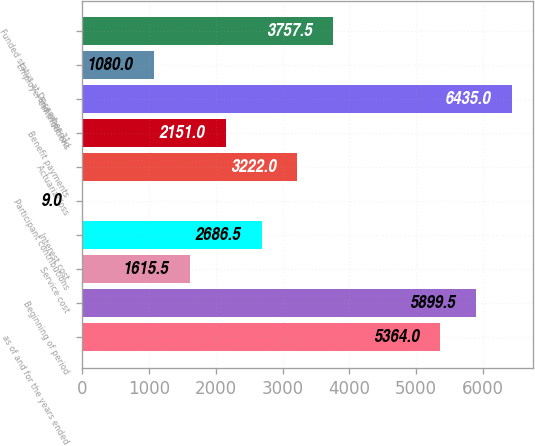Convert chart to OTSL. <chart><loc_0><loc_0><loc_500><loc_500><bar_chart><fcel>as of and for the years ended<fcel>Beginning of period<fcel>Service cost<fcel>Interest cost<fcel>Participant contributions<fcel>Actuarial loss<fcel>Benefit payments<fcel>End of period<fcel>Employer contributions<fcel>Funded status at December 31<nl><fcel>5364<fcel>5899.5<fcel>1615.5<fcel>2686.5<fcel>9<fcel>3222<fcel>2151<fcel>6435<fcel>1080<fcel>3757.5<nl></chart> 